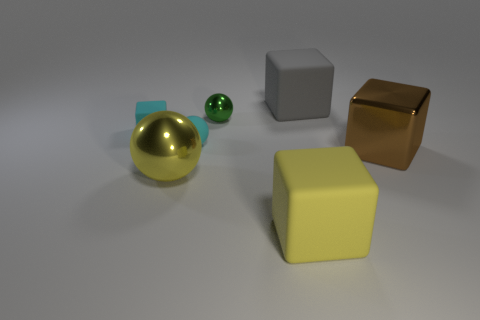Subtract all metallic blocks. How many blocks are left? 3 Add 1 metallic cubes. How many objects exist? 8 Subtract all cyan blocks. How many blocks are left? 3 Subtract 0 blue balls. How many objects are left? 7 Subtract all cubes. How many objects are left? 3 Subtract 3 cubes. How many cubes are left? 1 Subtract all cyan spheres. Subtract all cyan cylinders. How many spheres are left? 2 Subtract all red blocks. How many cyan balls are left? 1 Subtract all large blocks. Subtract all cyan blocks. How many objects are left? 3 Add 3 big objects. How many big objects are left? 7 